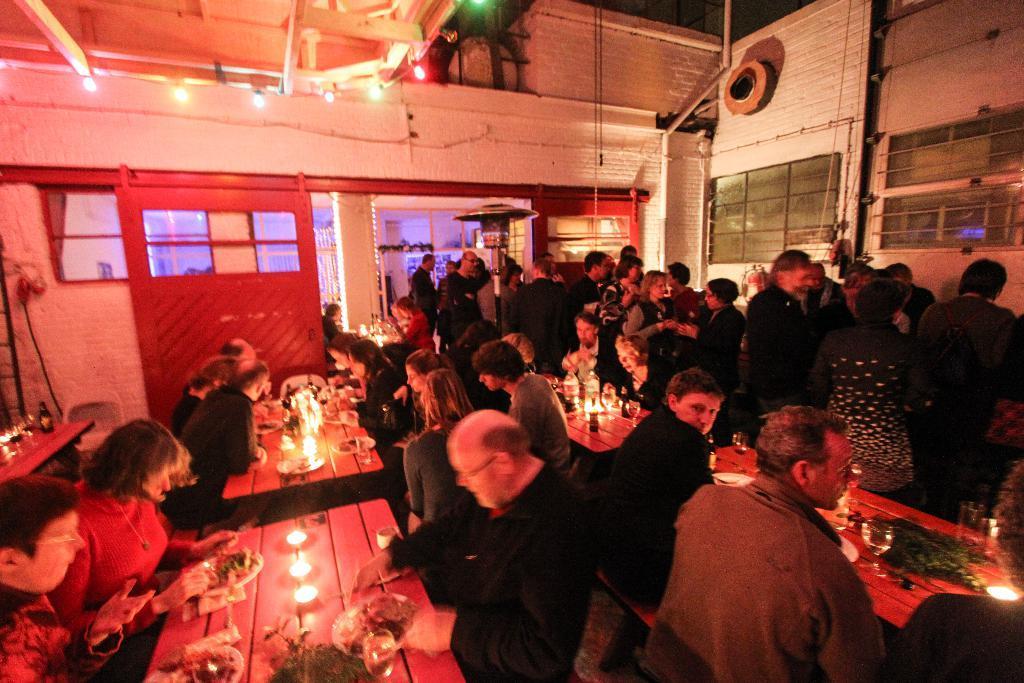In one or two sentences, can you explain what this image depicts? In this picture I can see some people were eating the food while sitting on the chair. On the right I can see another group of persons were standing near the table and door. On the table I can see the lights, food, plate and other objects. At the top I can see the lights and focus light. 